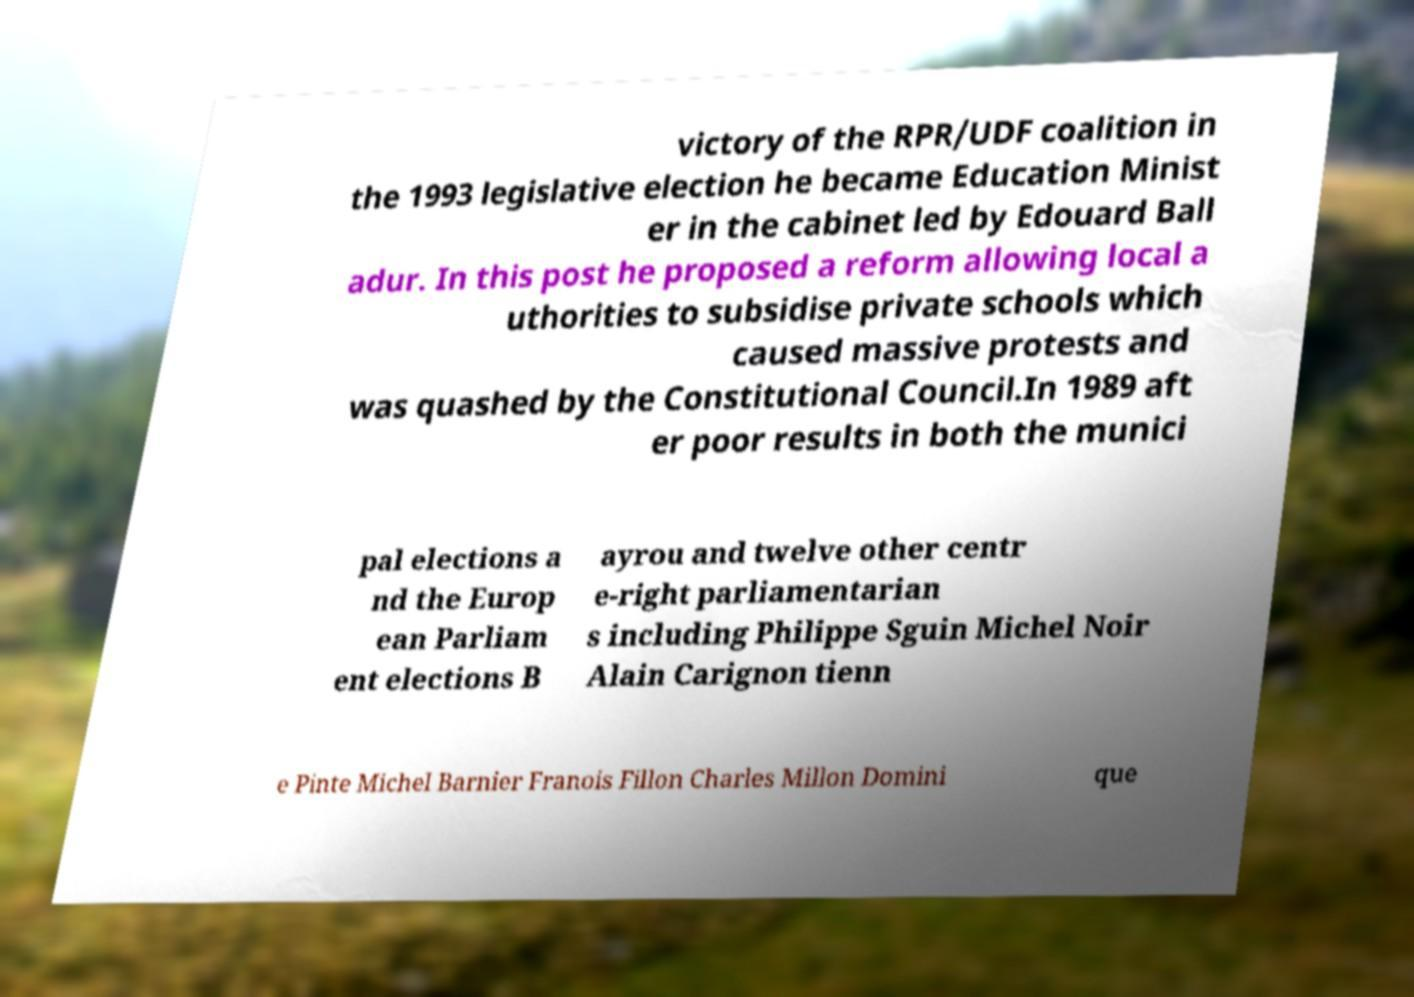I need the written content from this picture converted into text. Can you do that? victory of the RPR/UDF coalition in the 1993 legislative election he became Education Minist er in the cabinet led by Edouard Ball adur. In this post he proposed a reform allowing local a uthorities to subsidise private schools which caused massive protests and was quashed by the Constitutional Council.In 1989 aft er poor results in both the munici pal elections a nd the Europ ean Parliam ent elections B ayrou and twelve other centr e-right parliamentarian s including Philippe Sguin Michel Noir Alain Carignon tienn e Pinte Michel Barnier Franois Fillon Charles Millon Domini que 